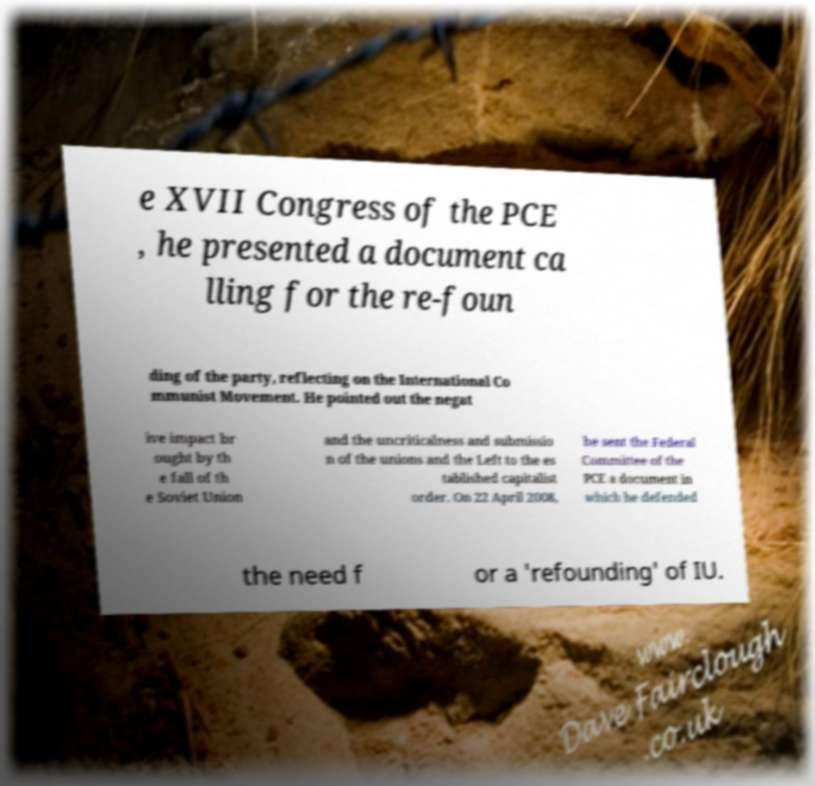Can you accurately transcribe the text from the provided image for me? e XVII Congress of the PCE , he presented a document ca lling for the re-foun ding of the party, reflecting on the International Co mmunist Movement. He pointed out the negat ive impact br ought by th e fall of th e Soviet Union and the uncriticalness and submissio n of the unions and the Left to the es tablished capitalist order. On 22 April 2008, he sent the Federal Committee of the PCE a document in which he defended the need f or a 'refounding' of IU. 